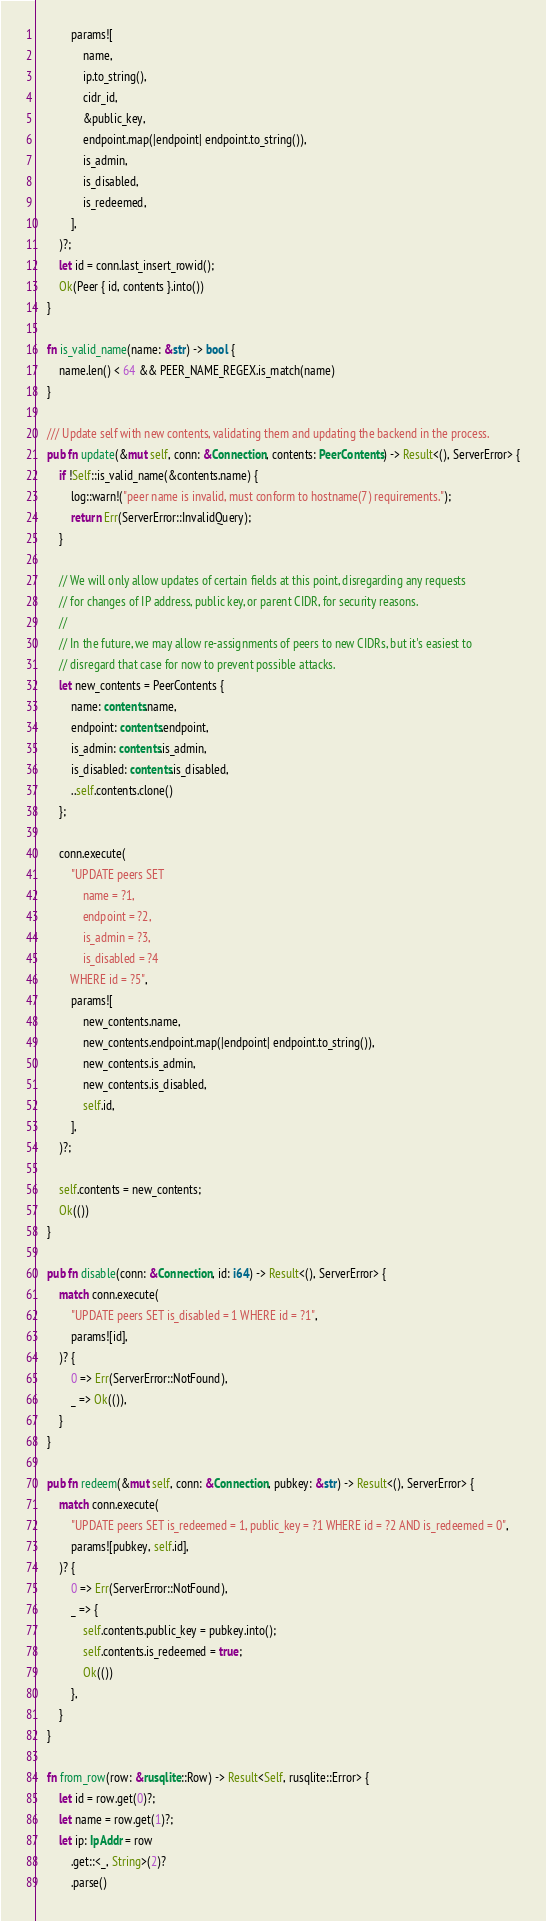<code> <loc_0><loc_0><loc_500><loc_500><_Rust_>            params![
                name,
                ip.to_string(),
                cidr_id,
                &public_key,
                endpoint.map(|endpoint| endpoint.to_string()),
                is_admin,
                is_disabled,
                is_redeemed,
            ],
        )?;
        let id = conn.last_insert_rowid();
        Ok(Peer { id, contents }.into())
    }

    fn is_valid_name(name: &str) -> bool {
        name.len() < 64 && PEER_NAME_REGEX.is_match(name)
    }

    /// Update self with new contents, validating them and updating the backend in the process.
    pub fn update(&mut self, conn: &Connection, contents: PeerContents) -> Result<(), ServerError> {
        if !Self::is_valid_name(&contents.name) {
            log::warn!("peer name is invalid, must conform to hostname(7) requirements.");
            return Err(ServerError::InvalidQuery);
        }

        // We will only allow updates of certain fields at this point, disregarding any requests
        // for changes of IP address, public key, or parent CIDR, for security reasons.
        //
        // In the future, we may allow re-assignments of peers to new CIDRs, but it's easiest to
        // disregard that case for now to prevent possible attacks.
        let new_contents = PeerContents {
            name: contents.name,
            endpoint: contents.endpoint,
            is_admin: contents.is_admin,
            is_disabled: contents.is_disabled,
            ..self.contents.clone()
        };

        conn.execute(
            "UPDATE peers SET
                name = ?1,
                endpoint = ?2,
                is_admin = ?3,
                is_disabled = ?4
            WHERE id = ?5",
            params![
                new_contents.name,
                new_contents.endpoint.map(|endpoint| endpoint.to_string()),
                new_contents.is_admin,
                new_contents.is_disabled,
                self.id,
            ],
        )?;

        self.contents = new_contents;
        Ok(())
    }

    pub fn disable(conn: &Connection, id: i64) -> Result<(), ServerError> {
        match conn.execute(
            "UPDATE peers SET is_disabled = 1 WHERE id = ?1",
            params![id],
        )? {
            0 => Err(ServerError::NotFound),
            _ => Ok(()),
        }
    }

    pub fn redeem(&mut self, conn: &Connection, pubkey: &str) -> Result<(), ServerError> {
        match conn.execute(
            "UPDATE peers SET is_redeemed = 1, public_key = ?1 WHERE id = ?2 AND is_redeemed = 0",
            params![pubkey, self.id],
        )? {
            0 => Err(ServerError::NotFound),
            _ => {
                self.contents.public_key = pubkey.into();
                self.contents.is_redeemed = true;
                Ok(())
            },
        }
    }

    fn from_row(row: &rusqlite::Row) -> Result<Self, rusqlite::Error> {
        let id = row.get(0)?;
        let name = row.get(1)?;
        let ip: IpAddr = row
            .get::<_, String>(2)?
            .parse()</code> 